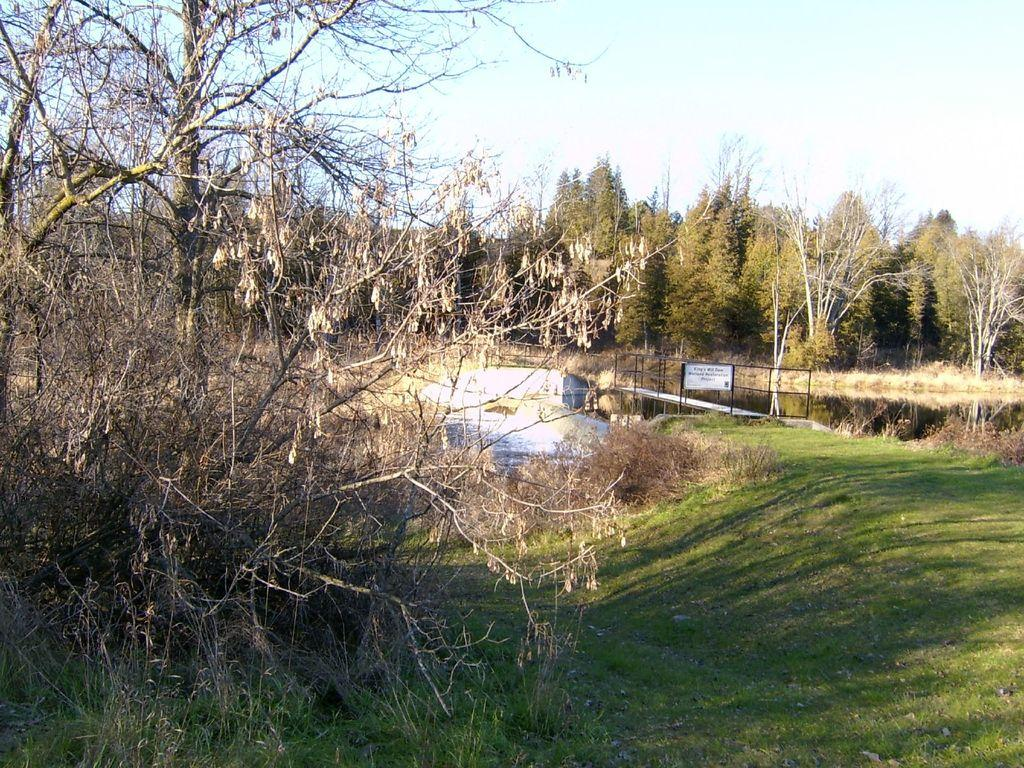What type of vegetation can be seen in the image? There are trees and grass in the image. Are the trees in the image alive or dead? The image contains both living trees and dried trees. What type of structure is present in the image? There is a bridge in the image. What body of water is visible in the image? There is a lake in the image. What can be seen in the background of the image? The sky is visible in the background of the image. What type of blade is being used by the fireman in the image? There is no fireman or blade present in the image. How does the bath in the image affect the water level of the lake? There is no bath present in the image, so it cannot affect the water level of the lake. 